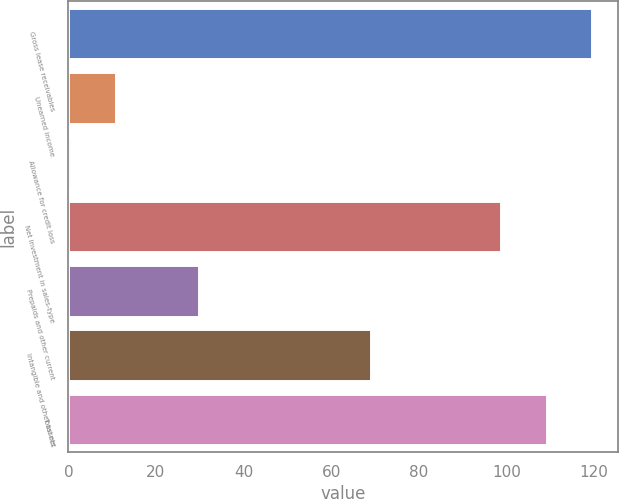Convert chart. <chart><loc_0><loc_0><loc_500><loc_500><bar_chart><fcel>Gross lease receivables<fcel>Unearned income<fcel>Allowance for credit loss<fcel>Net investment in sales-type<fcel>Prepaids and other current<fcel>Intangible and other assets<fcel>Total net<nl><fcel>119.64<fcel>10.97<fcel>0.6<fcel>98.9<fcel>29.8<fcel>69.1<fcel>109.27<nl></chart> 